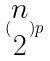<formula> <loc_0><loc_0><loc_500><loc_500>( \begin{matrix} n \\ 2 \end{matrix} ) p</formula> 